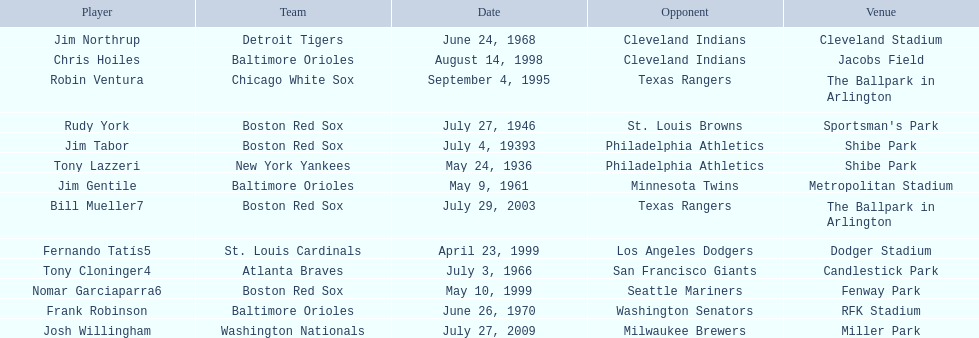Which teams played between the years 1960 and 1970? Baltimore Orioles, Atlanta Braves, Detroit Tigers, Baltimore Orioles. Of these teams that played, which ones played against the cleveland indians? Detroit Tigers. On what day did these two teams play? June 24, 1968. 